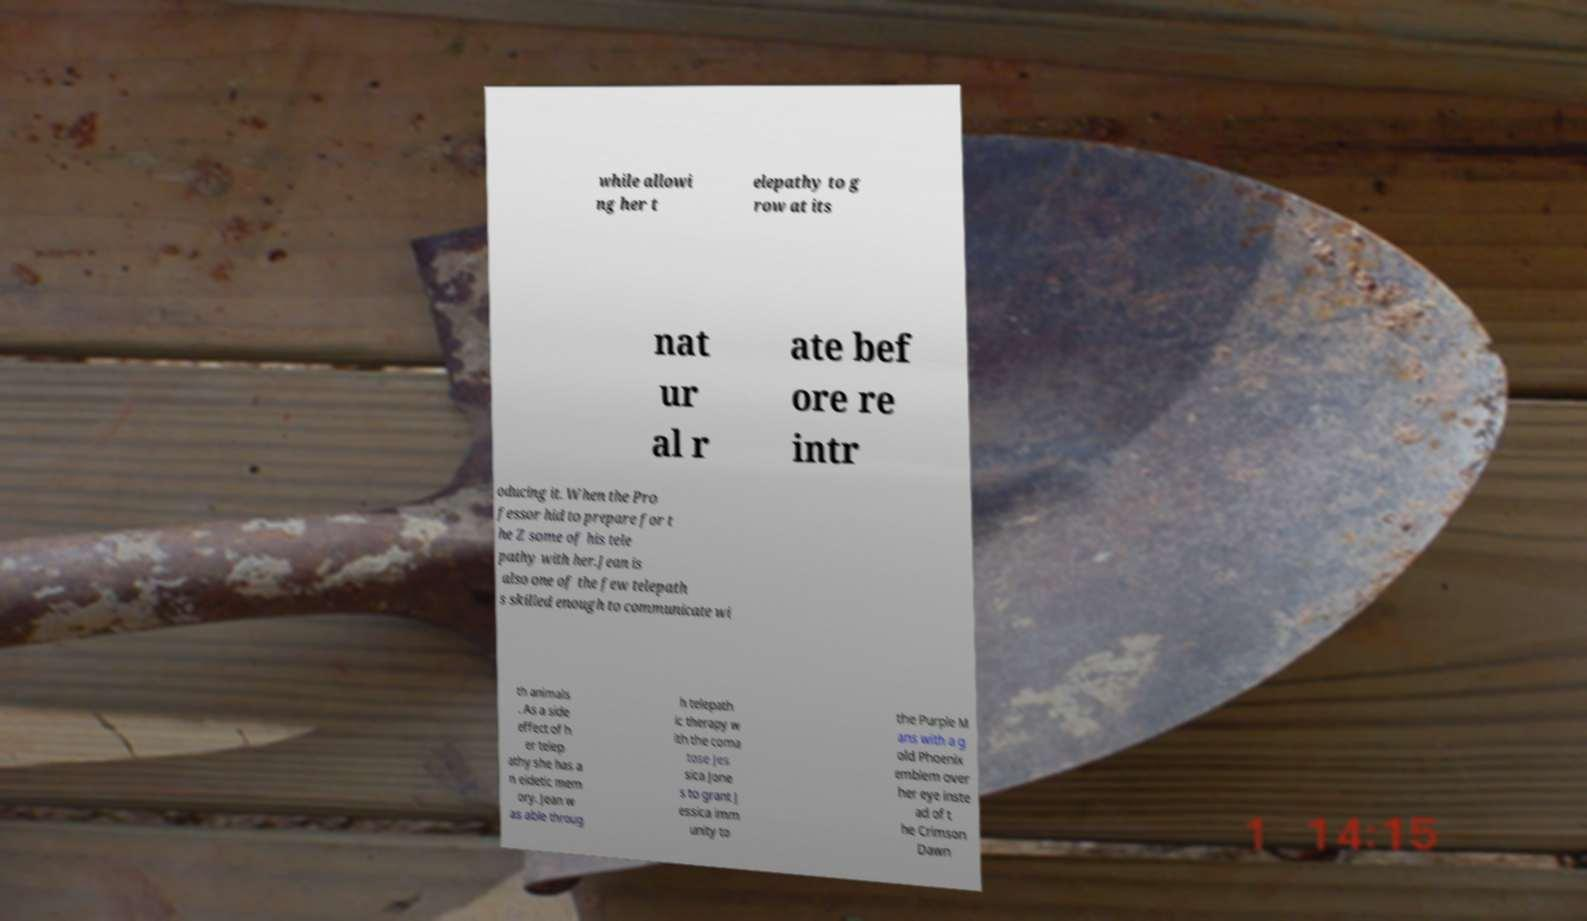There's text embedded in this image that I need extracted. Can you transcribe it verbatim? while allowi ng her t elepathy to g row at its nat ur al r ate bef ore re intr oducing it. When the Pro fessor hid to prepare for t he Z some of his tele pathy with her.Jean is also one of the few telepath s skilled enough to communicate wi th animals . As a side effect of h er telep athy she has a n eidetic mem ory. Jean w as able throug h telepath ic therapy w ith the coma tose Jes sica Jone s to grant J essica imm unity to the Purple M ans with a g old Phoenix emblem over her eye inste ad of t he Crimson Dawn 